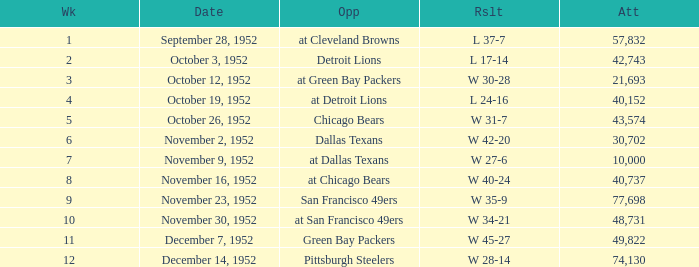When is the last week that has a result of a w 34-21? 10.0. 